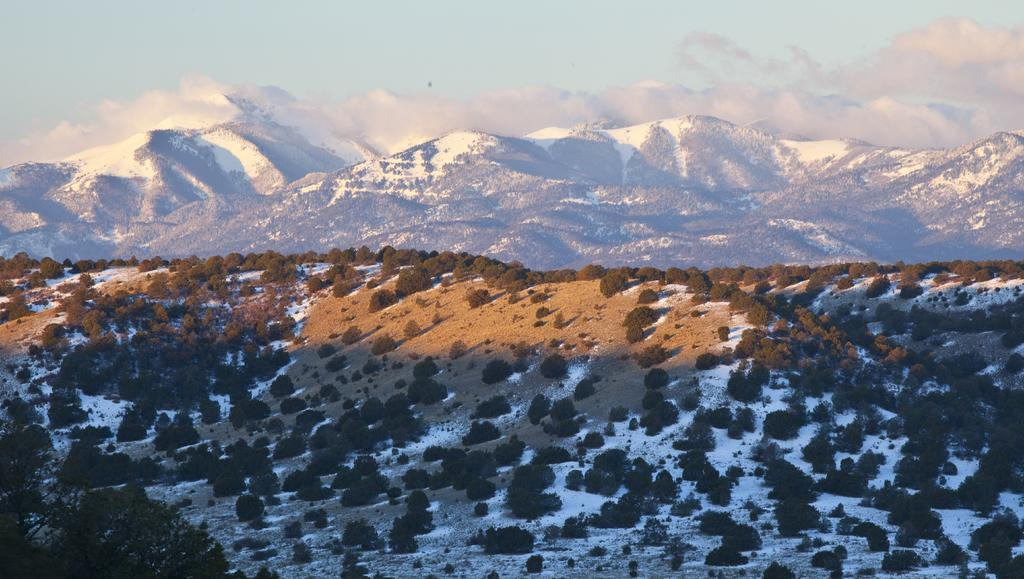What type of terrain is visible in the foreground of the image? There are trees, sand, and snow in the foreground of the image. What can be seen in the background of the image? There are mountains visible in the background of the image. What is visible in the sky in the image? The sky is visible in the image, and clouds are present. What type of shoes can be seen in the image? There are no shoes present in the image. What is the whip used for in the image? There is no whip present in the image. 